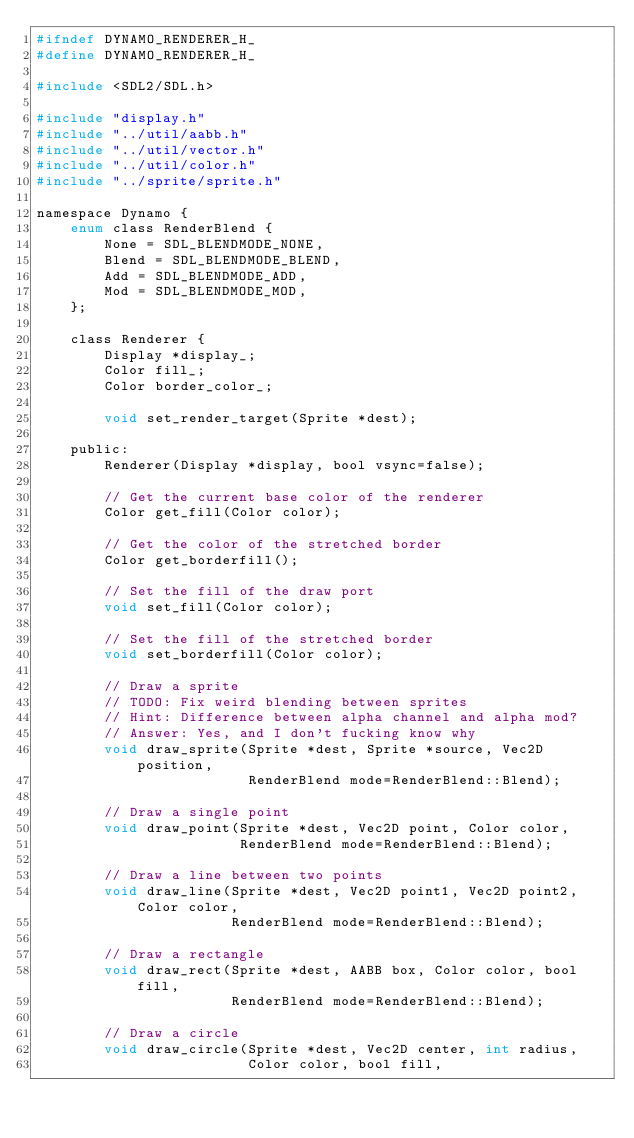Convert code to text. <code><loc_0><loc_0><loc_500><loc_500><_C_>#ifndef DYNAMO_RENDERER_H_
#define DYNAMO_RENDERER_H_

#include <SDL2/SDL.h>

#include "display.h"
#include "../util/aabb.h"
#include "../util/vector.h"
#include "../util/color.h"
#include "../sprite/sprite.h"

namespace Dynamo {
    enum class RenderBlend {
        None = SDL_BLENDMODE_NONE,
        Blend = SDL_BLENDMODE_BLEND,
        Add = SDL_BLENDMODE_ADD,
        Mod = SDL_BLENDMODE_MOD,
    };

    class Renderer {
        Display *display_;
        Color fill_;
        Color border_color_;

        void set_render_target(Sprite *dest);
    
    public:
        Renderer(Display *display, bool vsync=false);

        // Get the current base color of the renderer
        Color get_fill(Color color);

        // Get the color of the stretched border 
        Color get_borderfill();

        // Set the fill of the draw port
        void set_fill(Color color);

        // Set the fill of the stretched border
        void set_borderfill(Color color);

        // Draw a sprite
        // TODO: Fix weird blending between sprites
        // Hint: Difference between alpha channel and alpha mod?
        // Answer: Yes, and I don't fucking know why
        void draw_sprite(Sprite *dest, Sprite *source, Vec2D position, 
                         RenderBlend mode=RenderBlend::Blend);

        // Draw a single point
        void draw_point(Sprite *dest, Vec2D point, Color color, 
                        RenderBlend mode=RenderBlend::Blend);
        
        // Draw a line between two points
        void draw_line(Sprite *dest, Vec2D point1, Vec2D point2, Color color, 
                       RenderBlend mode=RenderBlend::Blend);
        
        // Draw a rectangle
        void draw_rect(Sprite *dest, AABB box, Color color, bool fill, 
                       RenderBlend mode=RenderBlend::Blend);

        // Draw a circle
        void draw_circle(Sprite *dest, Vec2D center, int radius, 
                         Color color, bool fill, </code> 